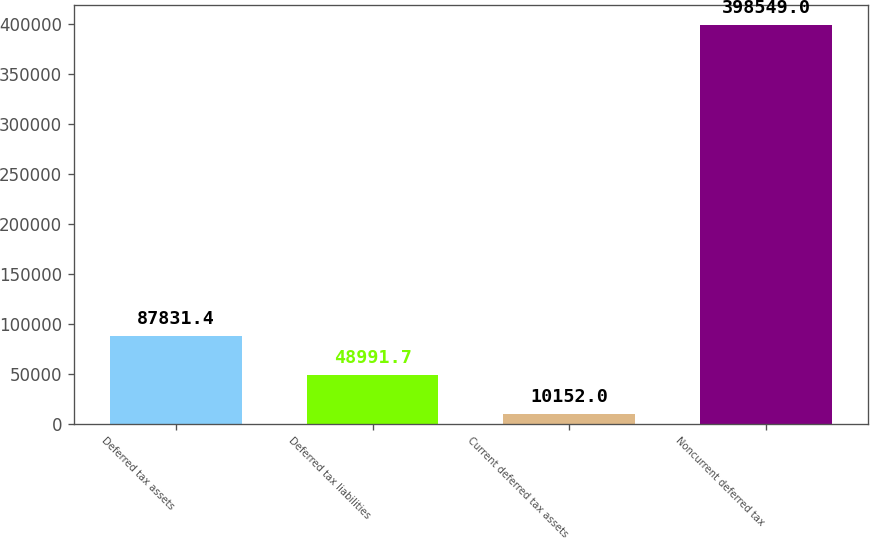Convert chart. <chart><loc_0><loc_0><loc_500><loc_500><bar_chart><fcel>Deferred tax assets<fcel>Deferred tax liabilities<fcel>Current deferred tax assets<fcel>Noncurrent deferred tax<nl><fcel>87831.4<fcel>48991.7<fcel>10152<fcel>398549<nl></chart> 